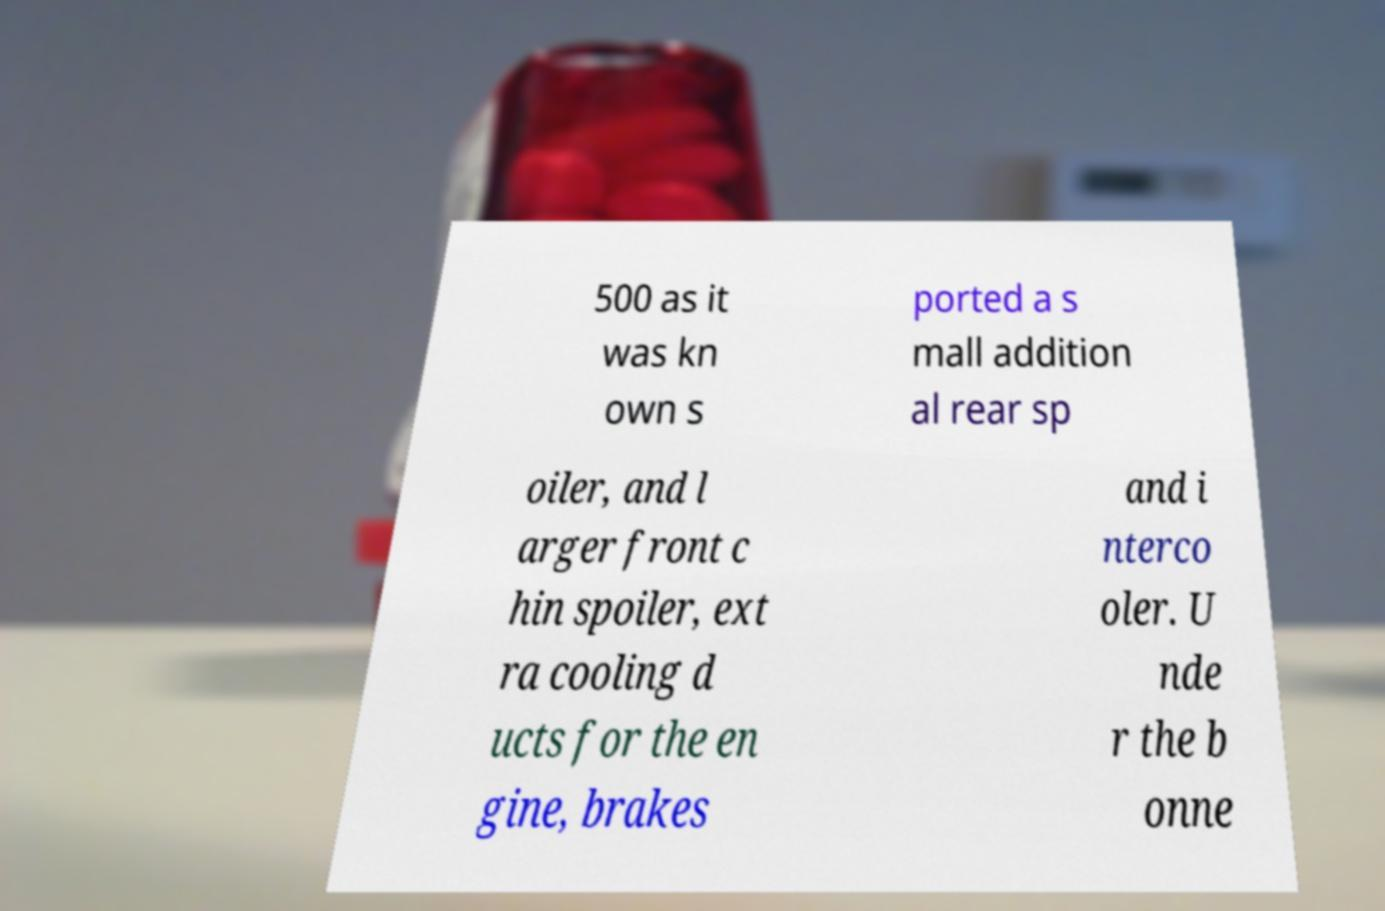Can you read and provide the text displayed in the image?This photo seems to have some interesting text. Can you extract and type it out for me? 500 as it was kn own s ported a s mall addition al rear sp oiler, and l arger front c hin spoiler, ext ra cooling d ucts for the en gine, brakes and i nterco oler. U nde r the b onne 